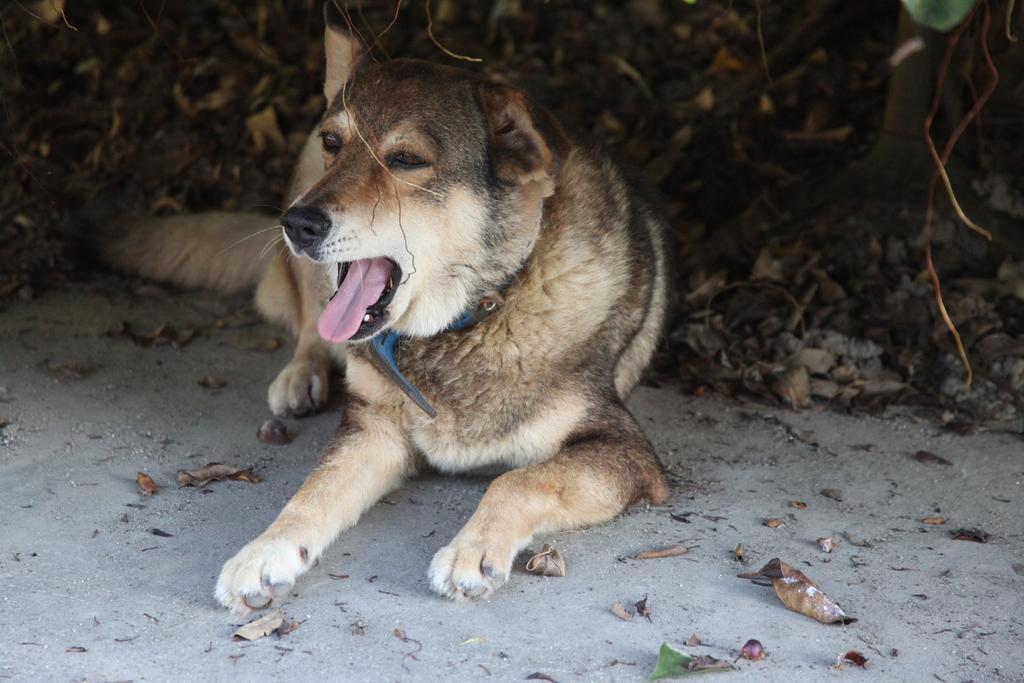Please provide a concise description of this image. In this image, in the middle there is a dog. At the bottom there are dry leaves, ground. In the background there are plants. 